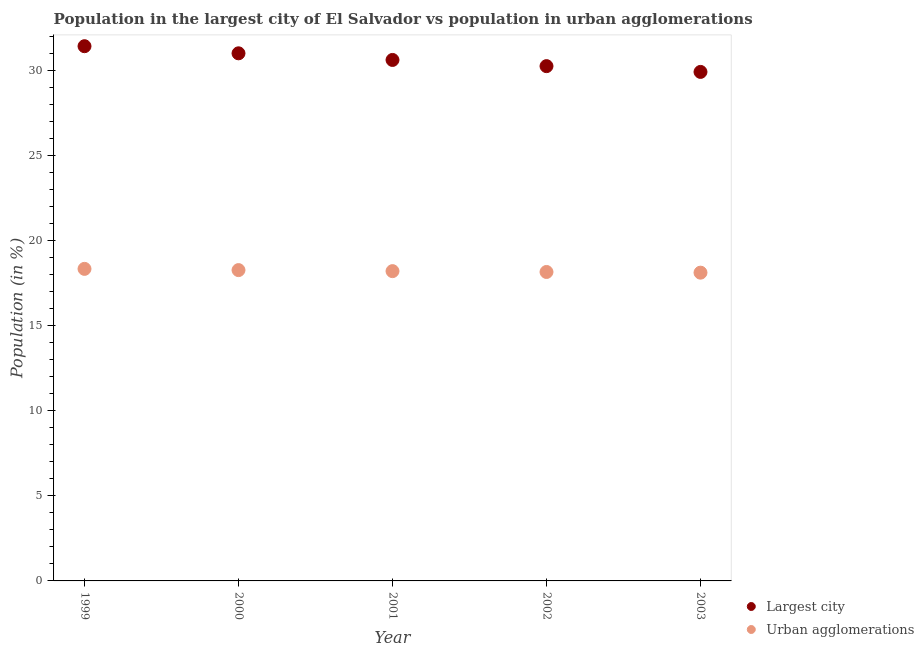How many different coloured dotlines are there?
Give a very brief answer. 2. What is the population in the largest city in 2001?
Your answer should be very brief. 30.62. Across all years, what is the maximum population in urban agglomerations?
Offer a terse response. 18.34. Across all years, what is the minimum population in urban agglomerations?
Offer a very short reply. 18.12. In which year was the population in the largest city minimum?
Offer a terse response. 2003. What is the total population in the largest city in the graph?
Your answer should be compact. 153.21. What is the difference between the population in the largest city in 2000 and that in 2002?
Ensure brevity in your answer.  0.75. What is the difference between the population in urban agglomerations in 2003 and the population in the largest city in 2002?
Give a very brief answer. -12.14. What is the average population in the largest city per year?
Your answer should be compact. 30.64. In the year 1999, what is the difference between the population in the largest city and population in urban agglomerations?
Give a very brief answer. 13.09. What is the ratio of the population in the largest city in 1999 to that in 2001?
Offer a terse response. 1.03. Is the population in the largest city in 2000 less than that in 2003?
Provide a short and direct response. No. What is the difference between the highest and the second highest population in urban agglomerations?
Your response must be concise. 0.07. What is the difference between the highest and the lowest population in urban agglomerations?
Your answer should be compact. 0.22. In how many years, is the population in the largest city greater than the average population in the largest city taken over all years?
Provide a succinct answer. 2. Is the sum of the population in urban agglomerations in 2002 and 2003 greater than the maximum population in the largest city across all years?
Provide a succinct answer. Yes. Is the population in urban agglomerations strictly greater than the population in the largest city over the years?
Offer a terse response. No. What is the difference between two consecutive major ticks on the Y-axis?
Your response must be concise. 5. Does the graph contain any zero values?
Make the answer very short. No. Where does the legend appear in the graph?
Offer a terse response. Bottom right. How many legend labels are there?
Provide a succinct answer. 2. How are the legend labels stacked?
Ensure brevity in your answer.  Vertical. What is the title of the graph?
Ensure brevity in your answer.  Population in the largest city of El Salvador vs population in urban agglomerations. What is the label or title of the X-axis?
Provide a short and direct response. Year. What is the Population (in %) in Largest city in 1999?
Make the answer very short. 31.42. What is the Population (in %) in Urban agglomerations in 1999?
Your answer should be very brief. 18.34. What is the Population (in %) of Largest city in 2000?
Give a very brief answer. 31.01. What is the Population (in %) in Urban agglomerations in 2000?
Provide a short and direct response. 18.27. What is the Population (in %) in Largest city in 2001?
Ensure brevity in your answer.  30.62. What is the Population (in %) of Urban agglomerations in 2001?
Provide a succinct answer. 18.21. What is the Population (in %) of Largest city in 2002?
Offer a very short reply. 30.25. What is the Population (in %) of Urban agglomerations in 2002?
Your answer should be very brief. 18.16. What is the Population (in %) of Largest city in 2003?
Your answer should be very brief. 29.91. What is the Population (in %) of Urban agglomerations in 2003?
Your answer should be very brief. 18.12. Across all years, what is the maximum Population (in %) of Largest city?
Offer a terse response. 31.42. Across all years, what is the maximum Population (in %) in Urban agglomerations?
Provide a short and direct response. 18.34. Across all years, what is the minimum Population (in %) of Largest city?
Provide a short and direct response. 29.91. Across all years, what is the minimum Population (in %) in Urban agglomerations?
Ensure brevity in your answer.  18.12. What is the total Population (in %) of Largest city in the graph?
Provide a succinct answer. 153.21. What is the total Population (in %) of Urban agglomerations in the graph?
Make the answer very short. 91.08. What is the difference between the Population (in %) in Largest city in 1999 and that in 2000?
Your answer should be compact. 0.42. What is the difference between the Population (in %) of Urban agglomerations in 1999 and that in 2000?
Provide a short and direct response. 0.07. What is the difference between the Population (in %) of Largest city in 1999 and that in 2001?
Keep it short and to the point. 0.81. What is the difference between the Population (in %) in Urban agglomerations in 1999 and that in 2001?
Keep it short and to the point. 0.13. What is the difference between the Population (in %) of Largest city in 1999 and that in 2002?
Offer a very short reply. 1.17. What is the difference between the Population (in %) of Urban agglomerations in 1999 and that in 2002?
Provide a short and direct response. 0.18. What is the difference between the Population (in %) of Largest city in 1999 and that in 2003?
Your answer should be very brief. 1.51. What is the difference between the Population (in %) in Urban agglomerations in 1999 and that in 2003?
Make the answer very short. 0.22. What is the difference between the Population (in %) of Largest city in 2000 and that in 2001?
Your answer should be very brief. 0.39. What is the difference between the Population (in %) in Urban agglomerations in 2000 and that in 2001?
Offer a terse response. 0.06. What is the difference between the Population (in %) in Largest city in 2000 and that in 2002?
Give a very brief answer. 0.75. What is the difference between the Population (in %) of Urban agglomerations in 2000 and that in 2002?
Ensure brevity in your answer.  0.11. What is the difference between the Population (in %) of Largest city in 2000 and that in 2003?
Keep it short and to the point. 1.09. What is the difference between the Population (in %) in Urban agglomerations in 2000 and that in 2003?
Provide a succinct answer. 0.15. What is the difference between the Population (in %) of Largest city in 2001 and that in 2002?
Your response must be concise. 0.36. What is the difference between the Population (in %) of Urban agglomerations in 2001 and that in 2002?
Your response must be concise. 0.05. What is the difference between the Population (in %) in Largest city in 2001 and that in 2003?
Offer a terse response. 0.7. What is the difference between the Population (in %) of Urban agglomerations in 2001 and that in 2003?
Make the answer very short. 0.09. What is the difference between the Population (in %) of Largest city in 2002 and that in 2003?
Make the answer very short. 0.34. What is the difference between the Population (in %) of Urban agglomerations in 2002 and that in 2003?
Provide a short and direct response. 0.04. What is the difference between the Population (in %) of Largest city in 1999 and the Population (in %) of Urban agglomerations in 2000?
Offer a terse response. 13.16. What is the difference between the Population (in %) of Largest city in 1999 and the Population (in %) of Urban agglomerations in 2001?
Provide a short and direct response. 13.22. What is the difference between the Population (in %) of Largest city in 1999 and the Population (in %) of Urban agglomerations in 2002?
Keep it short and to the point. 13.27. What is the difference between the Population (in %) in Largest city in 1999 and the Population (in %) in Urban agglomerations in 2003?
Offer a very short reply. 13.31. What is the difference between the Population (in %) of Largest city in 2000 and the Population (in %) of Urban agglomerations in 2001?
Your response must be concise. 12.8. What is the difference between the Population (in %) of Largest city in 2000 and the Population (in %) of Urban agglomerations in 2002?
Give a very brief answer. 12.85. What is the difference between the Population (in %) of Largest city in 2000 and the Population (in %) of Urban agglomerations in 2003?
Offer a terse response. 12.89. What is the difference between the Population (in %) of Largest city in 2001 and the Population (in %) of Urban agglomerations in 2002?
Your response must be concise. 12.46. What is the difference between the Population (in %) in Largest city in 2001 and the Population (in %) in Urban agglomerations in 2003?
Provide a succinct answer. 12.5. What is the difference between the Population (in %) in Largest city in 2002 and the Population (in %) in Urban agglomerations in 2003?
Offer a terse response. 12.14. What is the average Population (in %) of Largest city per year?
Your response must be concise. 30.64. What is the average Population (in %) in Urban agglomerations per year?
Provide a short and direct response. 18.22. In the year 1999, what is the difference between the Population (in %) in Largest city and Population (in %) in Urban agglomerations?
Provide a succinct answer. 13.09. In the year 2000, what is the difference between the Population (in %) of Largest city and Population (in %) of Urban agglomerations?
Keep it short and to the point. 12.74. In the year 2001, what is the difference between the Population (in %) of Largest city and Population (in %) of Urban agglomerations?
Keep it short and to the point. 12.41. In the year 2002, what is the difference between the Population (in %) of Largest city and Population (in %) of Urban agglomerations?
Provide a succinct answer. 12.1. In the year 2003, what is the difference between the Population (in %) in Largest city and Population (in %) in Urban agglomerations?
Make the answer very short. 11.8. What is the ratio of the Population (in %) in Largest city in 1999 to that in 2000?
Give a very brief answer. 1.01. What is the ratio of the Population (in %) in Largest city in 1999 to that in 2001?
Ensure brevity in your answer.  1.03. What is the ratio of the Population (in %) in Urban agglomerations in 1999 to that in 2001?
Ensure brevity in your answer.  1.01. What is the ratio of the Population (in %) in Largest city in 1999 to that in 2002?
Your answer should be compact. 1.04. What is the ratio of the Population (in %) of Largest city in 1999 to that in 2003?
Keep it short and to the point. 1.05. What is the ratio of the Population (in %) of Urban agglomerations in 1999 to that in 2003?
Offer a very short reply. 1.01. What is the ratio of the Population (in %) of Largest city in 2000 to that in 2001?
Keep it short and to the point. 1.01. What is the ratio of the Population (in %) of Urban agglomerations in 2000 to that in 2001?
Offer a very short reply. 1. What is the ratio of the Population (in %) in Largest city in 2000 to that in 2002?
Your response must be concise. 1.02. What is the ratio of the Population (in %) in Largest city in 2000 to that in 2003?
Offer a very short reply. 1.04. What is the ratio of the Population (in %) of Urban agglomerations in 2000 to that in 2003?
Your answer should be very brief. 1.01. What is the ratio of the Population (in %) of Largest city in 2001 to that in 2002?
Offer a very short reply. 1.01. What is the ratio of the Population (in %) of Largest city in 2001 to that in 2003?
Provide a short and direct response. 1.02. What is the ratio of the Population (in %) in Urban agglomerations in 2001 to that in 2003?
Keep it short and to the point. 1. What is the ratio of the Population (in %) in Largest city in 2002 to that in 2003?
Provide a short and direct response. 1.01. What is the ratio of the Population (in %) in Urban agglomerations in 2002 to that in 2003?
Make the answer very short. 1. What is the difference between the highest and the second highest Population (in %) in Largest city?
Provide a succinct answer. 0.42. What is the difference between the highest and the second highest Population (in %) in Urban agglomerations?
Your answer should be very brief. 0.07. What is the difference between the highest and the lowest Population (in %) in Largest city?
Ensure brevity in your answer.  1.51. What is the difference between the highest and the lowest Population (in %) of Urban agglomerations?
Provide a succinct answer. 0.22. 